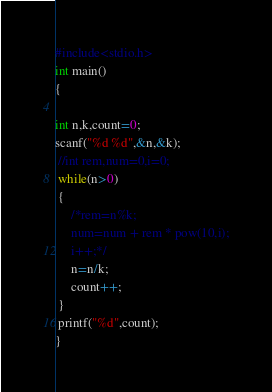<code> <loc_0><loc_0><loc_500><loc_500><_C_>#include<stdio.h>
int main()
{

int n,k,count=0;
scanf("%d %d",&n,&k);
 //int rem,num=0,i=0;
 while(n>0)
 {
     /*rem=n%k;
     num=num + rem * pow(10,i);
     i++;*/
     n=n/k;
     count++;
 }
 printf("%d",count);
}
</code> 